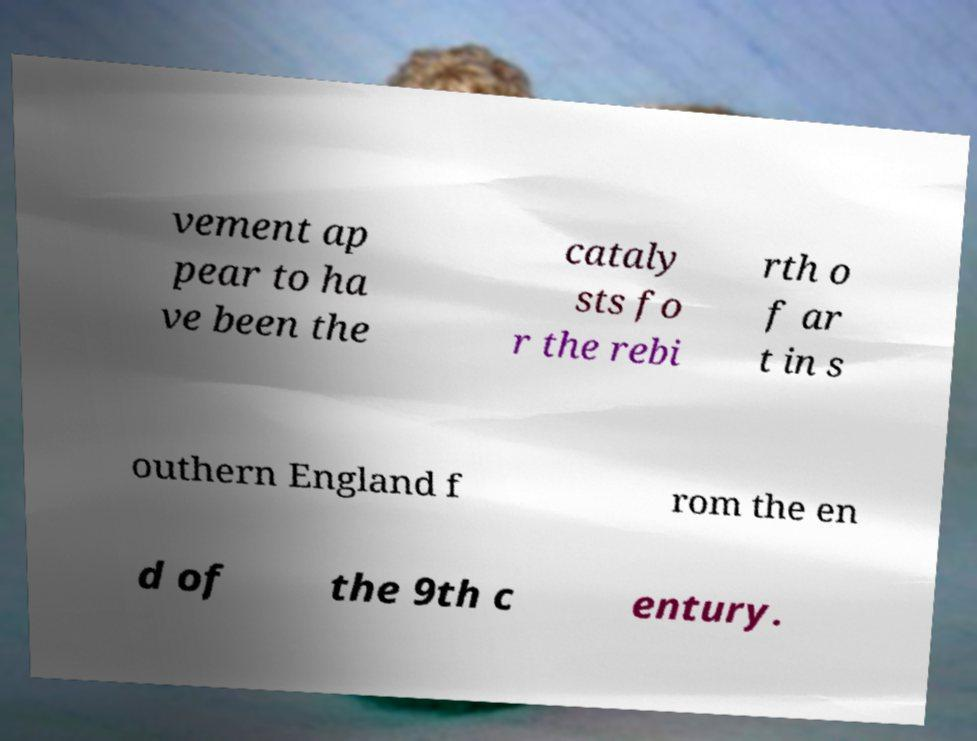Can you accurately transcribe the text from the provided image for me? vement ap pear to ha ve been the cataly sts fo r the rebi rth o f ar t in s outhern England f rom the en d of the 9th c entury. 